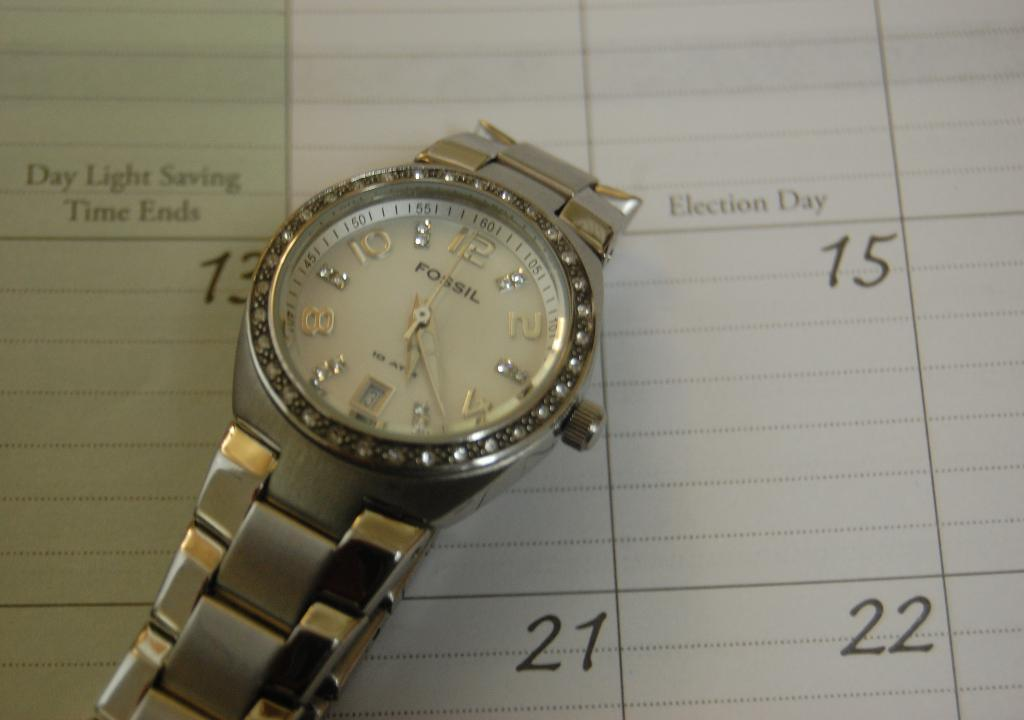What is the main object in the center of the image? There is a watch in the center of the image. What features does the watch have? The watch has hands and numbers. What else can be seen in the background of the image? There is text on a paper in the background of the image. What type of operation is being performed on the watch in the image? There is no operation being performed on the watch in the image; it is simply a watch with hands and numbers. Can you tell me how many springs are visible in the image? There are no springs visible in the image. 